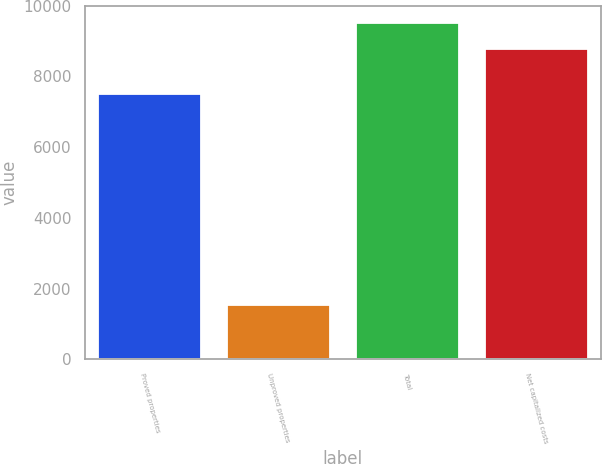Convert chart to OTSL. <chart><loc_0><loc_0><loc_500><loc_500><bar_chart><fcel>Proved properties<fcel>Unproved properties<fcel>Total<fcel>Net capitalized costs<nl><fcel>7510<fcel>1544<fcel>9525<fcel>8774<nl></chart> 